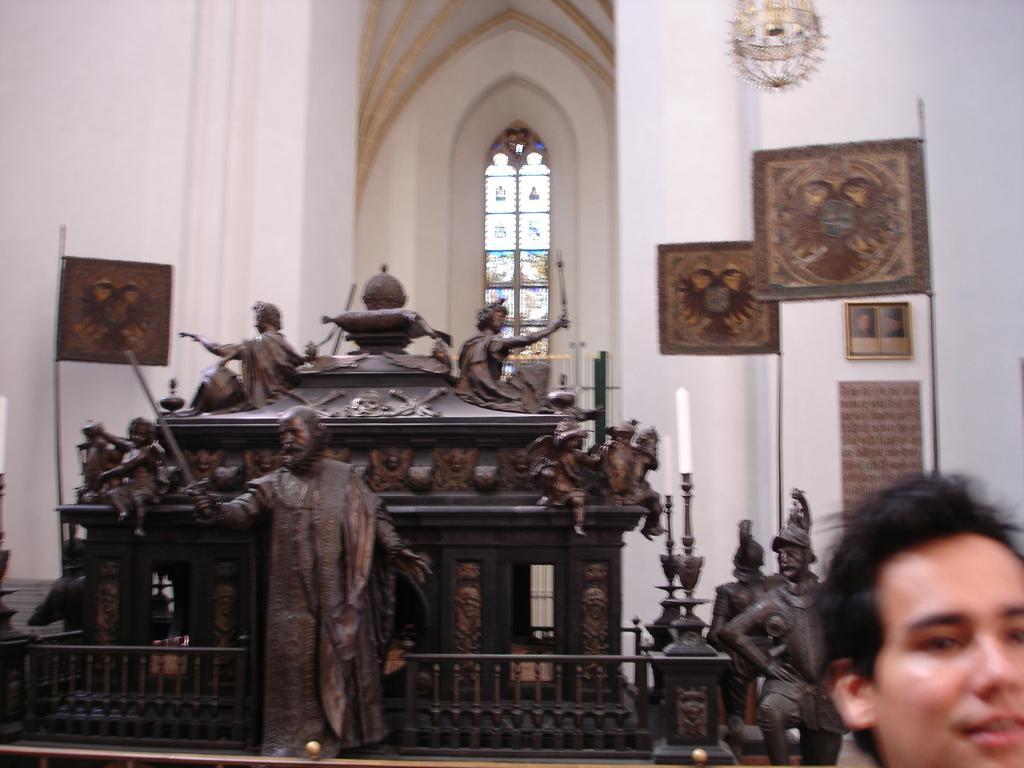Could you give a brief overview of what you see in this image? This image consists of a statue in the middle. There is a person's face in the bottom right corner. There are lights at the top. There are candles in the middle. 